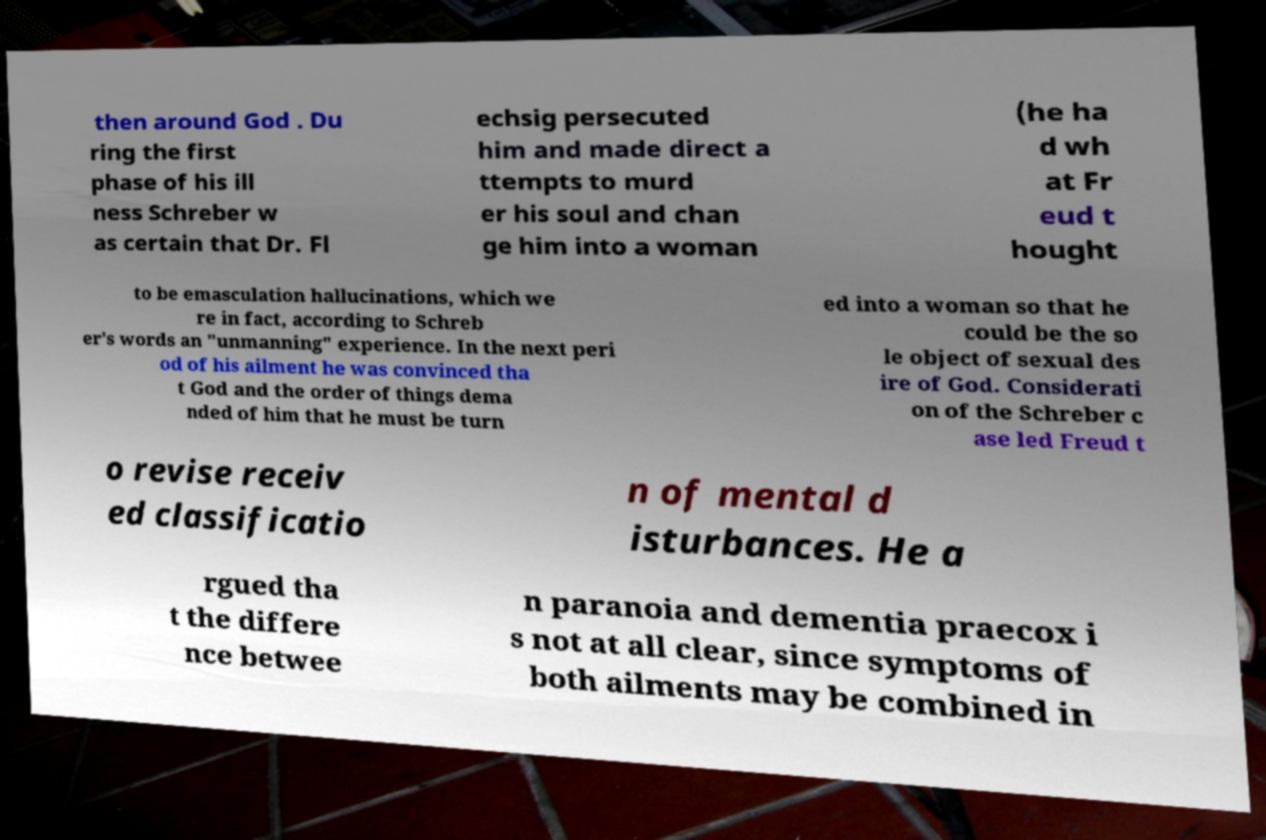What messages or text are displayed in this image? I need them in a readable, typed format. then around God . Du ring the first phase of his ill ness Schreber w as certain that Dr. Fl echsig persecuted him and made direct a ttempts to murd er his soul and chan ge him into a woman (he ha d wh at Fr eud t hought to be emasculation hallucinations, which we re in fact, according to Schreb er's words an "unmanning" experience. In the next peri od of his ailment he was convinced tha t God and the order of things dema nded of him that he must be turn ed into a woman so that he could be the so le object of sexual des ire of God. Considerati on of the Schreber c ase led Freud t o revise receiv ed classificatio n of mental d isturbances. He a rgued tha t the differe nce betwee n paranoia and dementia praecox i s not at all clear, since symptoms of both ailments may be combined in 